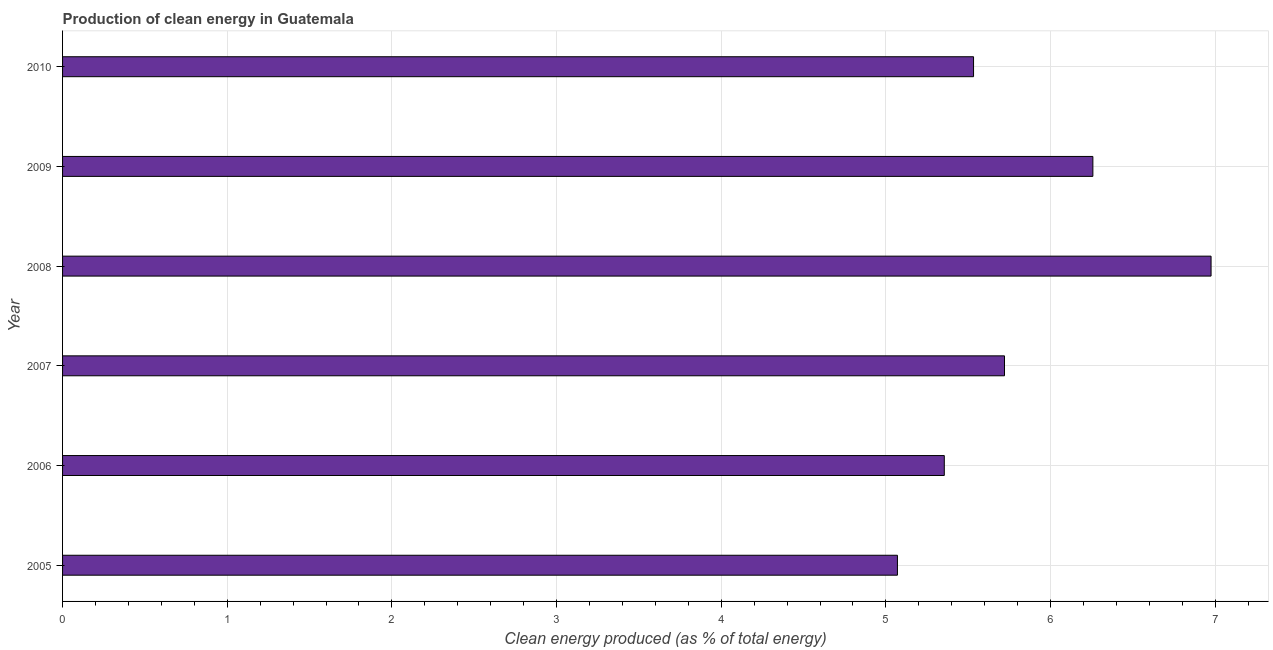What is the title of the graph?
Give a very brief answer. Production of clean energy in Guatemala. What is the label or title of the X-axis?
Your response must be concise. Clean energy produced (as % of total energy). What is the production of clean energy in 2010?
Your answer should be very brief. 5.53. Across all years, what is the maximum production of clean energy?
Provide a succinct answer. 6.97. Across all years, what is the minimum production of clean energy?
Your answer should be very brief. 5.07. In which year was the production of clean energy maximum?
Keep it short and to the point. 2008. What is the sum of the production of clean energy?
Give a very brief answer. 34.91. What is the difference between the production of clean energy in 2006 and 2008?
Give a very brief answer. -1.62. What is the average production of clean energy per year?
Make the answer very short. 5.82. What is the median production of clean energy?
Keep it short and to the point. 5.63. What is the ratio of the production of clean energy in 2005 to that in 2006?
Keep it short and to the point. 0.95. What is the difference between the highest and the second highest production of clean energy?
Provide a short and direct response. 0.72. Is the sum of the production of clean energy in 2005 and 2010 greater than the maximum production of clean energy across all years?
Your answer should be compact. Yes. What is the difference between the highest and the lowest production of clean energy?
Ensure brevity in your answer.  1.9. In how many years, is the production of clean energy greater than the average production of clean energy taken over all years?
Offer a very short reply. 2. How many bars are there?
Offer a very short reply. 6. What is the difference between two consecutive major ticks on the X-axis?
Ensure brevity in your answer.  1. Are the values on the major ticks of X-axis written in scientific E-notation?
Provide a succinct answer. No. What is the Clean energy produced (as % of total energy) in 2005?
Keep it short and to the point. 5.07. What is the Clean energy produced (as % of total energy) of 2006?
Make the answer very short. 5.35. What is the Clean energy produced (as % of total energy) in 2007?
Your response must be concise. 5.72. What is the Clean energy produced (as % of total energy) of 2008?
Offer a terse response. 6.97. What is the Clean energy produced (as % of total energy) of 2009?
Make the answer very short. 6.26. What is the Clean energy produced (as % of total energy) of 2010?
Give a very brief answer. 5.53. What is the difference between the Clean energy produced (as % of total energy) in 2005 and 2006?
Offer a very short reply. -0.28. What is the difference between the Clean energy produced (as % of total energy) in 2005 and 2007?
Make the answer very short. -0.65. What is the difference between the Clean energy produced (as % of total energy) in 2005 and 2008?
Provide a succinct answer. -1.9. What is the difference between the Clean energy produced (as % of total energy) in 2005 and 2009?
Provide a succinct answer. -1.19. What is the difference between the Clean energy produced (as % of total energy) in 2005 and 2010?
Your answer should be very brief. -0.46. What is the difference between the Clean energy produced (as % of total energy) in 2006 and 2007?
Your answer should be very brief. -0.37. What is the difference between the Clean energy produced (as % of total energy) in 2006 and 2008?
Offer a very short reply. -1.62. What is the difference between the Clean energy produced (as % of total energy) in 2006 and 2009?
Ensure brevity in your answer.  -0.9. What is the difference between the Clean energy produced (as % of total energy) in 2006 and 2010?
Provide a succinct answer. -0.18. What is the difference between the Clean energy produced (as % of total energy) in 2007 and 2008?
Provide a succinct answer. -1.25. What is the difference between the Clean energy produced (as % of total energy) in 2007 and 2009?
Ensure brevity in your answer.  -0.54. What is the difference between the Clean energy produced (as % of total energy) in 2007 and 2010?
Keep it short and to the point. 0.19. What is the difference between the Clean energy produced (as % of total energy) in 2008 and 2009?
Offer a very short reply. 0.72. What is the difference between the Clean energy produced (as % of total energy) in 2008 and 2010?
Provide a short and direct response. 1.44. What is the difference between the Clean energy produced (as % of total energy) in 2009 and 2010?
Your response must be concise. 0.72. What is the ratio of the Clean energy produced (as % of total energy) in 2005 to that in 2006?
Offer a terse response. 0.95. What is the ratio of the Clean energy produced (as % of total energy) in 2005 to that in 2007?
Ensure brevity in your answer.  0.89. What is the ratio of the Clean energy produced (as % of total energy) in 2005 to that in 2008?
Your answer should be compact. 0.73. What is the ratio of the Clean energy produced (as % of total energy) in 2005 to that in 2009?
Give a very brief answer. 0.81. What is the ratio of the Clean energy produced (as % of total energy) in 2005 to that in 2010?
Ensure brevity in your answer.  0.92. What is the ratio of the Clean energy produced (as % of total energy) in 2006 to that in 2007?
Offer a terse response. 0.94. What is the ratio of the Clean energy produced (as % of total energy) in 2006 to that in 2008?
Provide a succinct answer. 0.77. What is the ratio of the Clean energy produced (as % of total energy) in 2006 to that in 2009?
Make the answer very short. 0.86. What is the ratio of the Clean energy produced (as % of total energy) in 2006 to that in 2010?
Make the answer very short. 0.97. What is the ratio of the Clean energy produced (as % of total energy) in 2007 to that in 2008?
Your answer should be compact. 0.82. What is the ratio of the Clean energy produced (as % of total energy) in 2007 to that in 2009?
Keep it short and to the point. 0.91. What is the ratio of the Clean energy produced (as % of total energy) in 2007 to that in 2010?
Your answer should be very brief. 1.03. What is the ratio of the Clean energy produced (as % of total energy) in 2008 to that in 2009?
Give a very brief answer. 1.11. What is the ratio of the Clean energy produced (as % of total energy) in 2008 to that in 2010?
Ensure brevity in your answer.  1.26. What is the ratio of the Clean energy produced (as % of total energy) in 2009 to that in 2010?
Keep it short and to the point. 1.13. 